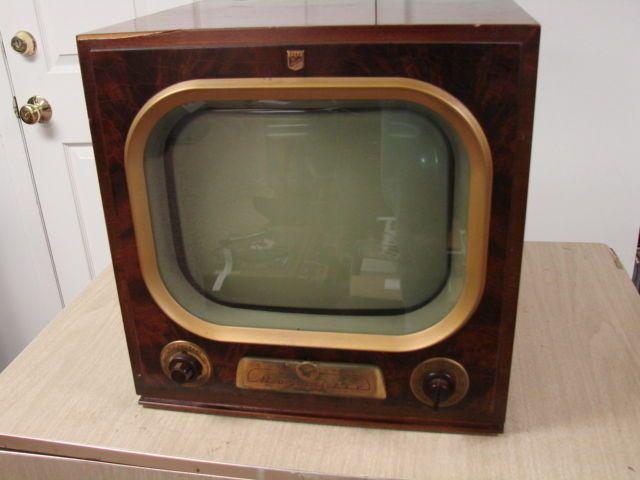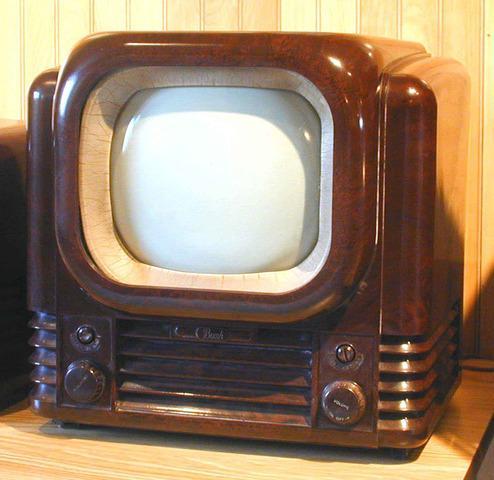The first image is the image on the left, the second image is the image on the right. For the images displayed, is the sentence "the controls are right of the screen in the image on the right" factually correct? Answer yes or no. No. The first image is the image on the left, the second image is the image on the right. Given the left and right images, does the statement "Two old televisions have brown cases." hold true? Answer yes or no. Yes. 